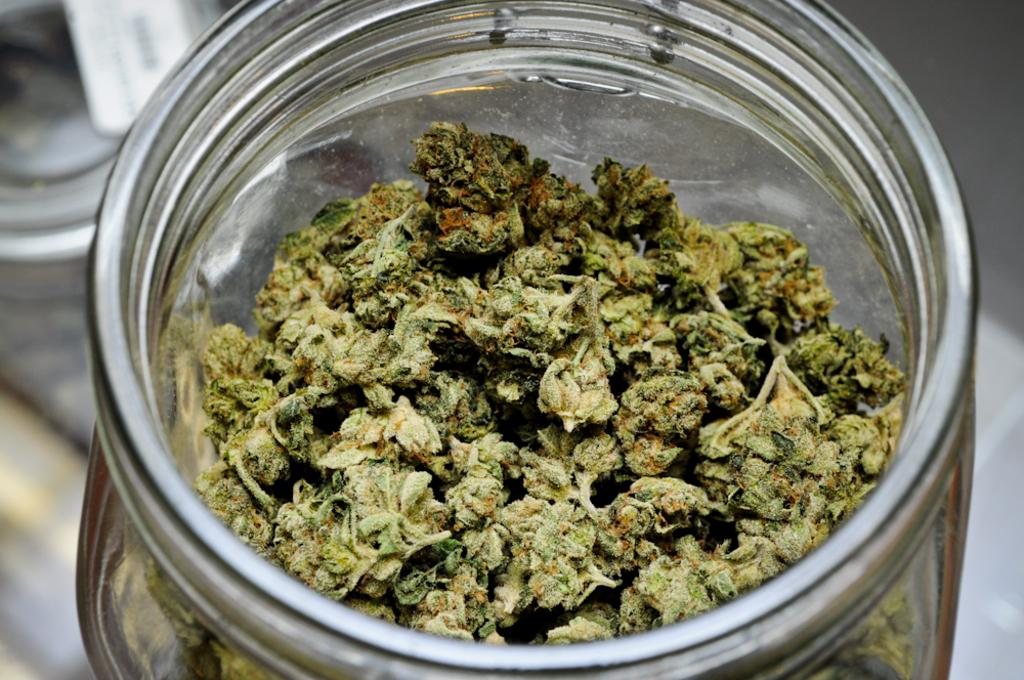What is contained within the jar in the image? There are food items in a jar in the image. What type of railway is visible in the image? There is no railway present in the image; it features a jar with food items. What type of jeans are being worn by the fowl in the image? There is no fowl or jeans present in the image. 